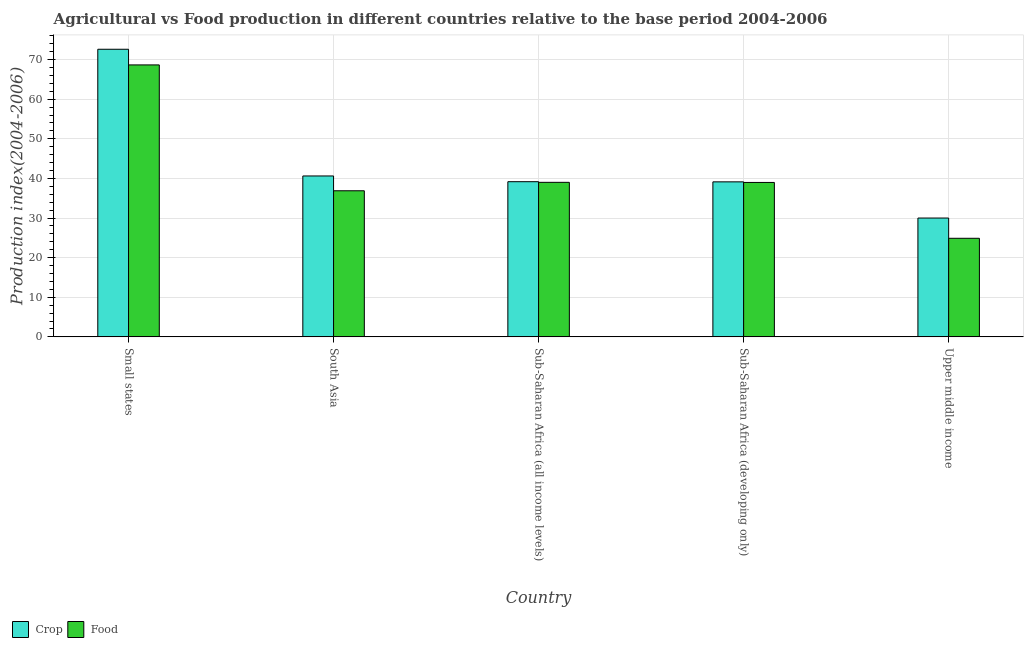How many groups of bars are there?
Your answer should be very brief. 5. Are the number of bars per tick equal to the number of legend labels?
Your answer should be compact. Yes. How many bars are there on the 1st tick from the right?
Keep it short and to the point. 2. What is the label of the 1st group of bars from the left?
Provide a succinct answer. Small states. What is the food production index in Sub-Saharan Africa (developing only)?
Offer a terse response. 38.98. Across all countries, what is the maximum crop production index?
Provide a short and direct response. 72.6. Across all countries, what is the minimum crop production index?
Your response must be concise. 29.99. In which country was the crop production index maximum?
Ensure brevity in your answer.  Small states. In which country was the crop production index minimum?
Offer a terse response. Upper middle income. What is the total crop production index in the graph?
Make the answer very short. 221.5. What is the difference between the crop production index in South Asia and that in Sub-Saharan Africa (all income levels)?
Ensure brevity in your answer.  1.45. What is the difference between the crop production index in Sub-Saharan Africa (all income levels) and the food production index in South Asia?
Ensure brevity in your answer.  2.29. What is the average crop production index per country?
Your answer should be compact. 44.3. What is the difference between the food production index and crop production index in Upper middle income?
Give a very brief answer. -5.11. In how many countries, is the food production index greater than 36 ?
Your answer should be very brief. 4. What is the ratio of the crop production index in South Asia to that in Sub-Saharan Africa (all income levels)?
Your response must be concise. 1.04. What is the difference between the highest and the second highest food production index?
Your response must be concise. 29.64. What is the difference between the highest and the lowest food production index?
Offer a very short reply. 43.76. Is the sum of the food production index in Small states and Sub-Saharan Africa (developing only) greater than the maximum crop production index across all countries?
Offer a very short reply. Yes. What does the 1st bar from the left in South Asia represents?
Your answer should be compact. Crop. What does the 1st bar from the right in Sub-Saharan Africa (all income levels) represents?
Your answer should be very brief. Food. How many bars are there?
Your answer should be very brief. 10. Are the values on the major ticks of Y-axis written in scientific E-notation?
Your response must be concise. No. Does the graph contain any zero values?
Provide a succinct answer. No. Does the graph contain grids?
Provide a succinct answer. Yes. How are the legend labels stacked?
Offer a very short reply. Horizontal. What is the title of the graph?
Offer a terse response. Agricultural vs Food production in different countries relative to the base period 2004-2006. What is the label or title of the X-axis?
Make the answer very short. Country. What is the label or title of the Y-axis?
Give a very brief answer. Production index(2004-2006). What is the Production index(2004-2006) of Crop in Small states?
Offer a very short reply. 72.6. What is the Production index(2004-2006) of Food in Small states?
Offer a terse response. 68.64. What is the Production index(2004-2006) in Crop in South Asia?
Provide a short and direct response. 40.61. What is the Production index(2004-2006) of Food in South Asia?
Offer a terse response. 36.88. What is the Production index(2004-2006) in Crop in Sub-Saharan Africa (all income levels)?
Your answer should be compact. 39.17. What is the Production index(2004-2006) of Food in Sub-Saharan Africa (all income levels)?
Ensure brevity in your answer.  39.01. What is the Production index(2004-2006) of Crop in Sub-Saharan Africa (developing only)?
Make the answer very short. 39.13. What is the Production index(2004-2006) of Food in Sub-Saharan Africa (developing only)?
Provide a short and direct response. 38.98. What is the Production index(2004-2006) in Crop in Upper middle income?
Provide a short and direct response. 29.99. What is the Production index(2004-2006) of Food in Upper middle income?
Provide a short and direct response. 24.88. Across all countries, what is the maximum Production index(2004-2006) in Crop?
Give a very brief answer. 72.6. Across all countries, what is the maximum Production index(2004-2006) in Food?
Keep it short and to the point. 68.64. Across all countries, what is the minimum Production index(2004-2006) of Crop?
Make the answer very short. 29.99. Across all countries, what is the minimum Production index(2004-2006) in Food?
Keep it short and to the point. 24.88. What is the total Production index(2004-2006) of Crop in the graph?
Give a very brief answer. 221.5. What is the total Production index(2004-2006) in Food in the graph?
Your answer should be compact. 208.39. What is the difference between the Production index(2004-2006) in Crop in Small states and that in South Asia?
Provide a succinct answer. 31.98. What is the difference between the Production index(2004-2006) of Food in Small states and that in South Asia?
Give a very brief answer. 31.76. What is the difference between the Production index(2004-2006) in Crop in Small states and that in Sub-Saharan Africa (all income levels)?
Offer a very short reply. 33.43. What is the difference between the Production index(2004-2006) in Food in Small states and that in Sub-Saharan Africa (all income levels)?
Your response must be concise. 29.64. What is the difference between the Production index(2004-2006) of Crop in Small states and that in Sub-Saharan Africa (developing only)?
Make the answer very short. 33.47. What is the difference between the Production index(2004-2006) in Food in Small states and that in Sub-Saharan Africa (developing only)?
Your response must be concise. 29.66. What is the difference between the Production index(2004-2006) of Crop in Small states and that in Upper middle income?
Give a very brief answer. 42.6. What is the difference between the Production index(2004-2006) in Food in Small states and that in Upper middle income?
Offer a very short reply. 43.76. What is the difference between the Production index(2004-2006) in Crop in South Asia and that in Sub-Saharan Africa (all income levels)?
Your answer should be compact. 1.45. What is the difference between the Production index(2004-2006) of Food in South Asia and that in Sub-Saharan Africa (all income levels)?
Offer a terse response. -2.13. What is the difference between the Production index(2004-2006) in Crop in South Asia and that in Sub-Saharan Africa (developing only)?
Your answer should be very brief. 1.49. What is the difference between the Production index(2004-2006) of Food in South Asia and that in Sub-Saharan Africa (developing only)?
Ensure brevity in your answer.  -2.1. What is the difference between the Production index(2004-2006) of Crop in South Asia and that in Upper middle income?
Your answer should be very brief. 10.62. What is the difference between the Production index(2004-2006) in Food in South Asia and that in Upper middle income?
Offer a very short reply. 12. What is the difference between the Production index(2004-2006) in Crop in Sub-Saharan Africa (all income levels) and that in Sub-Saharan Africa (developing only)?
Ensure brevity in your answer.  0.04. What is the difference between the Production index(2004-2006) of Food in Sub-Saharan Africa (all income levels) and that in Sub-Saharan Africa (developing only)?
Give a very brief answer. 0.03. What is the difference between the Production index(2004-2006) of Crop in Sub-Saharan Africa (all income levels) and that in Upper middle income?
Offer a very short reply. 9.17. What is the difference between the Production index(2004-2006) in Food in Sub-Saharan Africa (all income levels) and that in Upper middle income?
Provide a succinct answer. 14.13. What is the difference between the Production index(2004-2006) of Crop in Sub-Saharan Africa (developing only) and that in Upper middle income?
Offer a very short reply. 9.13. What is the difference between the Production index(2004-2006) in Food in Sub-Saharan Africa (developing only) and that in Upper middle income?
Offer a terse response. 14.1. What is the difference between the Production index(2004-2006) of Crop in Small states and the Production index(2004-2006) of Food in South Asia?
Your response must be concise. 35.72. What is the difference between the Production index(2004-2006) of Crop in Small states and the Production index(2004-2006) of Food in Sub-Saharan Africa (all income levels)?
Provide a succinct answer. 33.59. What is the difference between the Production index(2004-2006) of Crop in Small states and the Production index(2004-2006) of Food in Sub-Saharan Africa (developing only)?
Your answer should be compact. 33.62. What is the difference between the Production index(2004-2006) of Crop in Small states and the Production index(2004-2006) of Food in Upper middle income?
Keep it short and to the point. 47.71. What is the difference between the Production index(2004-2006) of Crop in South Asia and the Production index(2004-2006) of Food in Sub-Saharan Africa (all income levels)?
Give a very brief answer. 1.61. What is the difference between the Production index(2004-2006) in Crop in South Asia and the Production index(2004-2006) in Food in Sub-Saharan Africa (developing only)?
Make the answer very short. 1.63. What is the difference between the Production index(2004-2006) of Crop in South Asia and the Production index(2004-2006) of Food in Upper middle income?
Make the answer very short. 15.73. What is the difference between the Production index(2004-2006) of Crop in Sub-Saharan Africa (all income levels) and the Production index(2004-2006) of Food in Sub-Saharan Africa (developing only)?
Your response must be concise. 0.19. What is the difference between the Production index(2004-2006) of Crop in Sub-Saharan Africa (all income levels) and the Production index(2004-2006) of Food in Upper middle income?
Offer a very short reply. 14.28. What is the difference between the Production index(2004-2006) in Crop in Sub-Saharan Africa (developing only) and the Production index(2004-2006) in Food in Upper middle income?
Give a very brief answer. 14.24. What is the average Production index(2004-2006) in Crop per country?
Keep it short and to the point. 44.3. What is the average Production index(2004-2006) in Food per country?
Your answer should be very brief. 41.68. What is the difference between the Production index(2004-2006) in Crop and Production index(2004-2006) in Food in Small states?
Your response must be concise. 3.95. What is the difference between the Production index(2004-2006) in Crop and Production index(2004-2006) in Food in South Asia?
Offer a very short reply. 3.74. What is the difference between the Production index(2004-2006) of Crop and Production index(2004-2006) of Food in Sub-Saharan Africa (all income levels)?
Provide a succinct answer. 0.16. What is the difference between the Production index(2004-2006) in Crop and Production index(2004-2006) in Food in Sub-Saharan Africa (developing only)?
Your answer should be very brief. 0.15. What is the difference between the Production index(2004-2006) in Crop and Production index(2004-2006) in Food in Upper middle income?
Your answer should be compact. 5.11. What is the ratio of the Production index(2004-2006) in Crop in Small states to that in South Asia?
Keep it short and to the point. 1.79. What is the ratio of the Production index(2004-2006) of Food in Small states to that in South Asia?
Provide a short and direct response. 1.86. What is the ratio of the Production index(2004-2006) in Crop in Small states to that in Sub-Saharan Africa (all income levels)?
Provide a short and direct response. 1.85. What is the ratio of the Production index(2004-2006) in Food in Small states to that in Sub-Saharan Africa (all income levels)?
Offer a terse response. 1.76. What is the ratio of the Production index(2004-2006) of Crop in Small states to that in Sub-Saharan Africa (developing only)?
Your answer should be very brief. 1.86. What is the ratio of the Production index(2004-2006) of Food in Small states to that in Sub-Saharan Africa (developing only)?
Ensure brevity in your answer.  1.76. What is the ratio of the Production index(2004-2006) of Crop in Small states to that in Upper middle income?
Give a very brief answer. 2.42. What is the ratio of the Production index(2004-2006) of Food in Small states to that in Upper middle income?
Your response must be concise. 2.76. What is the ratio of the Production index(2004-2006) in Crop in South Asia to that in Sub-Saharan Africa (all income levels)?
Keep it short and to the point. 1.04. What is the ratio of the Production index(2004-2006) of Food in South Asia to that in Sub-Saharan Africa (all income levels)?
Keep it short and to the point. 0.95. What is the ratio of the Production index(2004-2006) of Crop in South Asia to that in Sub-Saharan Africa (developing only)?
Ensure brevity in your answer.  1.04. What is the ratio of the Production index(2004-2006) of Food in South Asia to that in Sub-Saharan Africa (developing only)?
Provide a succinct answer. 0.95. What is the ratio of the Production index(2004-2006) in Crop in South Asia to that in Upper middle income?
Offer a very short reply. 1.35. What is the ratio of the Production index(2004-2006) of Food in South Asia to that in Upper middle income?
Give a very brief answer. 1.48. What is the ratio of the Production index(2004-2006) of Crop in Sub-Saharan Africa (all income levels) to that in Sub-Saharan Africa (developing only)?
Your answer should be compact. 1. What is the ratio of the Production index(2004-2006) of Crop in Sub-Saharan Africa (all income levels) to that in Upper middle income?
Offer a terse response. 1.31. What is the ratio of the Production index(2004-2006) in Food in Sub-Saharan Africa (all income levels) to that in Upper middle income?
Keep it short and to the point. 1.57. What is the ratio of the Production index(2004-2006) in Crop in Sub-Saharan Africa (developing only) to that in Upper middle income?
Your response must be concise. 1.3. What is the ratio of the Production index(2004-2006) of Food in Sub-Saharan Africa (developing only) to that in Upper middle income?
Ensure brevity in your answer.  1.57. What is the difference between the highest and the second highest Production index(2004-2006) in Crop?
Provide a short and direct response. 31.98. What is the difference between the highest and the second highest Production index(2004-2006) of Food?
Provide a short and direct response. 29.64. What is the difference between the highest and the lowest Production index(2004-2006) in Crop?
Provide a succinct answer. 42.6. What is the difference between the highest and the lowest Production index(2004-2006) of Food?
Keep it short and to the point. 43.76. 